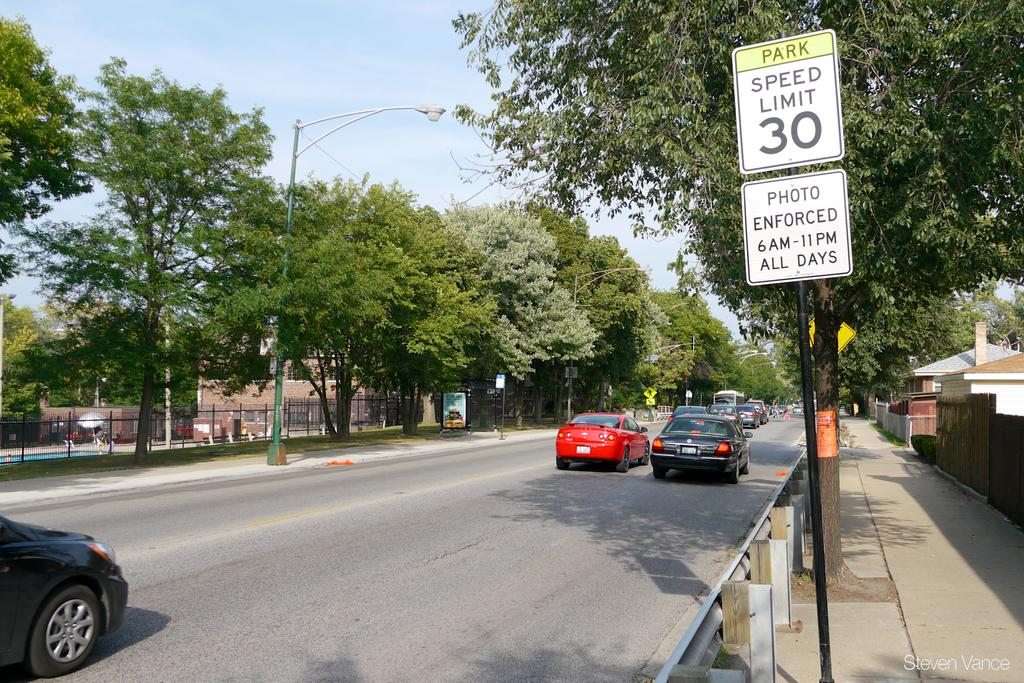<image>
Render a clear and concise summary of the photo. A sign under the speed limit says that driving is photo enforced every day. 